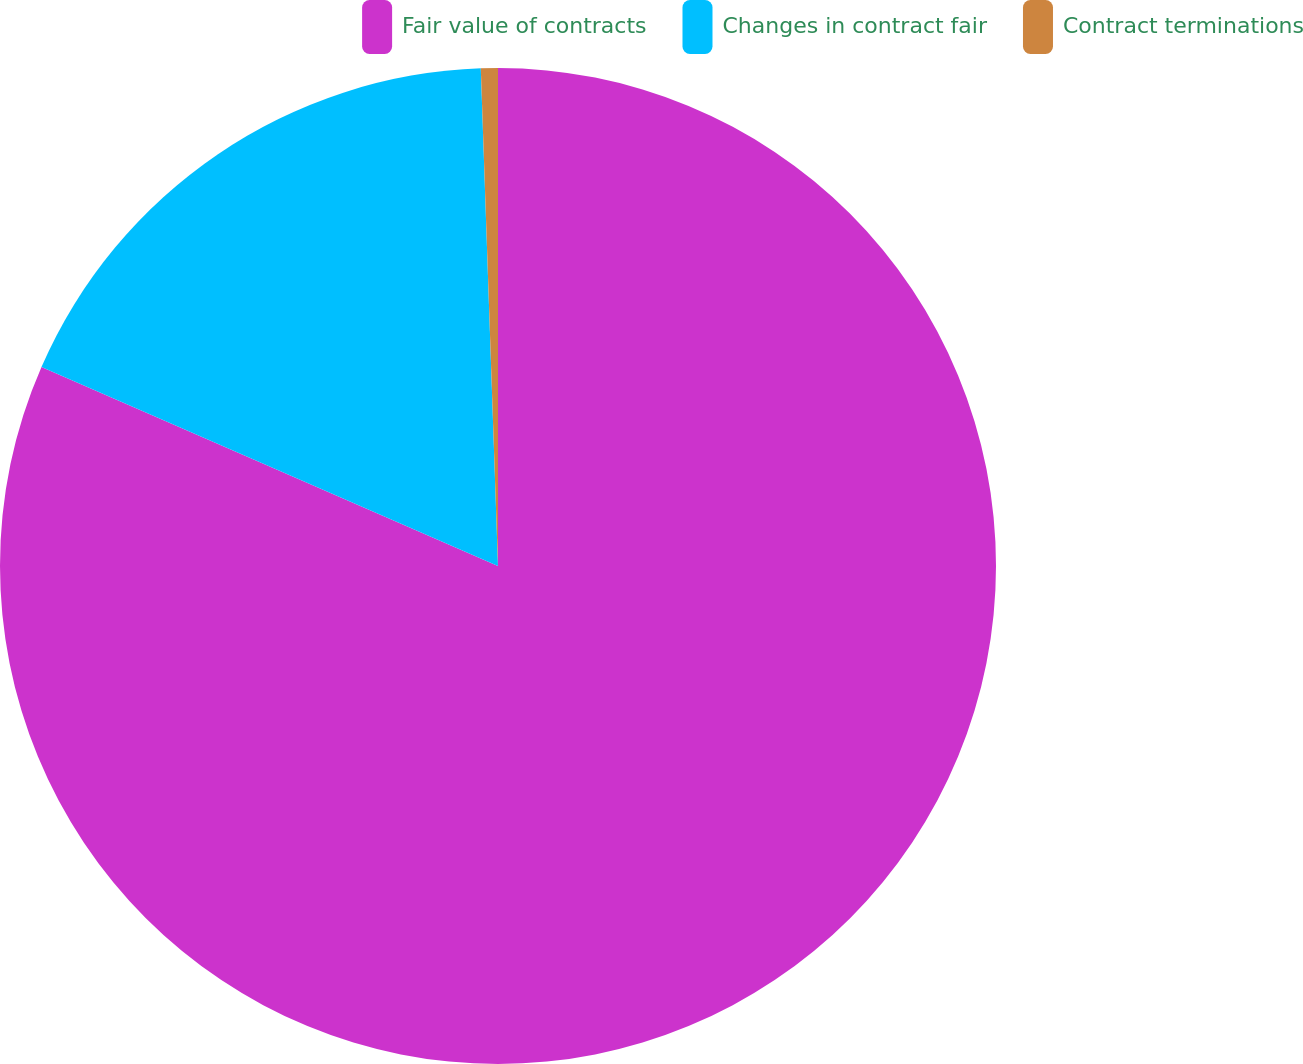Convert chart to OTSL. <chart><loc_0><loc_0><loc_500><loc_500><pie_chart><fcel>Fair value of contracts<fcel>Changes in contract fair<fcel>Contract terminations<nl><fcel>81.55%<fcel>17.91%<fcel>0.55%<nl></chart> 